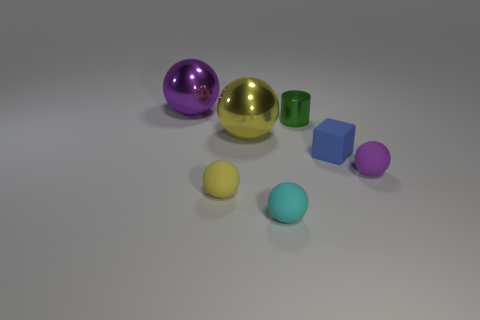Subtract all yellow spheres. How many spheres are left? 3 Subtract all cyan balls. How many balls are left? 4 Add 1 tiny purple balls. How many objects exist? 8 Subtract all blue balls. Subtract all blue cylinders. How many balls are left? 5 Subtract all balls. How many objects are left? 2 Add 6 tiny cyan matte objects. How many tiny cyan matte objects are left? 7 Add 2 small metallic objects. How many small metallic objects exist? 3 Subtract 1 purple balls. How many objects are left? 6 Subtract all small purple balls. Subtract all small cyan matte balls. How many objects are left? 5 